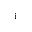<formula> <loc_0><loc_0><loc_500><loc_500>_ { i }</formula> 